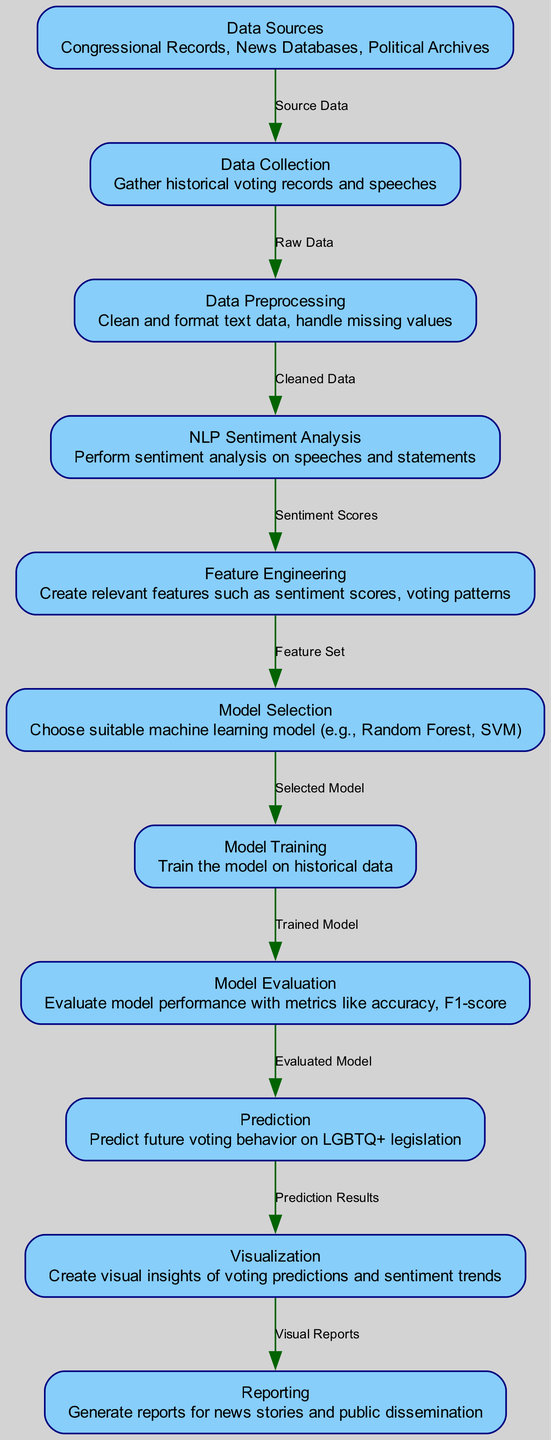What is the starting point of data flow? The first node in the diagram is "Data Sources," which indicates where the data originates. This is evidenced by the edge leading from "Data Sources" to "Data Collection," representing the beginning of the data flow.
Answer: Data Sources How many nodes are present in the diagram? By counting the distinct elements labeled in the diagram, there are a total of eleven nodes listed, depicting all stages of the machine learning process.
Answer: Eleven What type of analysis is performed on the speeches? The diagram specifies "NLP Sentiment Analysis" as the processing done on speeches and statements to derive sentiment scores, indicated by the direct connection from "data_preprocessing" to "nlp_sentiment_analysis."
Answer: NLP Sentiment Analysis What does the "Visualization" node generate? The edge from "visualization" to "reporting" indicates that the output from visualization is converted into "Visual Reports," which are likely to display insights and findings.
Answer: Visual Reports Which node follows "Model Evaluation"? The diagram shows an edge leading from "model_evaluation" to "prediction," indicating that the evaluation of the model precedes making predictions on future voting behavior.
Answer: Prediction What is the relationship between "Data Preprocessing" and "NLP Sentiment Analysis"? The edge labeled "Cleaned Data" establishes a direct connection between "data_preprocessing" and "nlp_sentiment_analysis," signifying that the cleaning and formatting of data are prerequisites for conducting sentiment analysis.
Answer: Cleaned Data Which machine learning models are mentioned for selection? The "Model Selection" node states that suitable models like Random Forest and SVM are to be chosen; while the details are not shown directly in the diagram, the node implies these are among the options explored.
Answer: Random Forest, SVM What is created in the "Feature Engineering" node? This node elaborates that relevant features such as sentiment scores and voting patterns are produced, which serve as inputs for model selection, as seen from the connecting edge labeled "Feature Set."
Answer: Sentiment scores, voting patterns How is the flow from "Prediction" to "Visualization" characterized? The relationship is marked by the edge representing "Prediction Results," denoting that the outcomes from predicting future voting behavior are visually represented in the visualization stage.
Answer: Prediction Results 